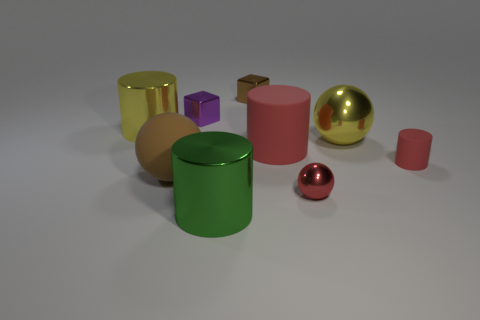Subtract all big yellow cylinders. How many cylinders are left? 3 Subtract all green cylinders. How many cylinders are left? 3 Subtract 0 red cubes. How many objects are left? 9 Subtract all cylinders. How many objects are left? 5 Subtract 2 cylinders. How many cylinders are left? 2 Subtract all purple cubes. Subtract all brown spheres. How many cubes are left? 1 Subtract all red cylinders. How many purple cubes are left? 1 Subtract all big purple rubber things. Subtract all green objects. How many objects are left? 8 Add 5 small matte cylinders. How many small matte cylinders are left? 6 Add 8 cyan matte cubes. How many cyan matte cubes exist? 8 